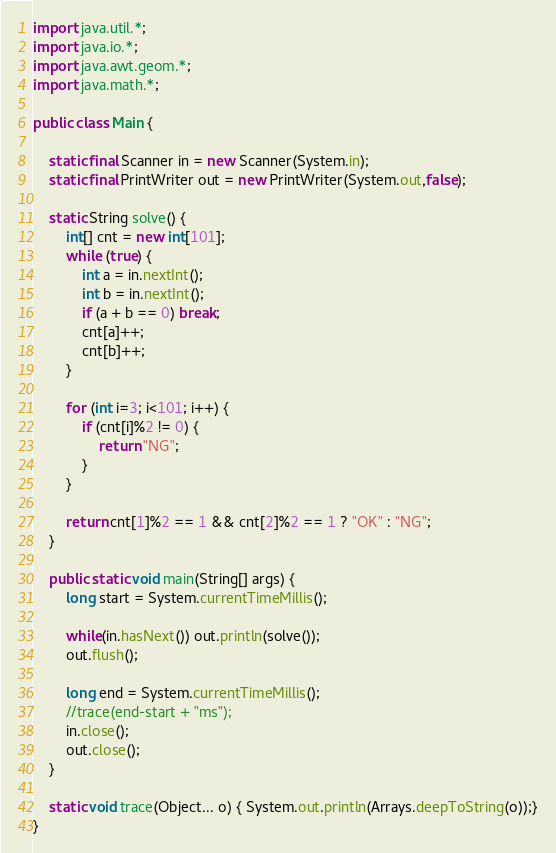Convert code to text. <code><loc_0><loc_0><loc_500><loc_500><_Java_>import java.util.*;
import java.io.*;
import java.awt.geom.*;
import java.math.*;

public class Main {

	static final Scanner in = new Scanner(System.in);
	static final PrintWriter out = new PrintWriter(System.out,false);

	static String solve() {
		int[] cnt = new int[101];
		while (true) {
			int a = in.nextInt();
			int b = in.nextInt();
			if (a + b == 0) break;
			cnt[a]++;
			cnt[b]++;
		}

		for (int i=3; i<101; i++) {
			if (cnt[i]%2 != 0) {
				return "NG";
			}
		}

		return cnt[1]%2 == 1 && cnt[2]%2 == 1 ? "OK" : "NG";
	}

	public static void main(String[] args) {
		long start = System.currentTimeMillis();

		while(in.hasNext()) out.println(solve());
		out.flush();

		long end = System.currentTimeMillis();
		//trace(end-start + "ms");
		in.close();
		out.close();
	}

	static void trace(Object... o) { System.out.println(Arrays.deepToString(o));}
}</code> 